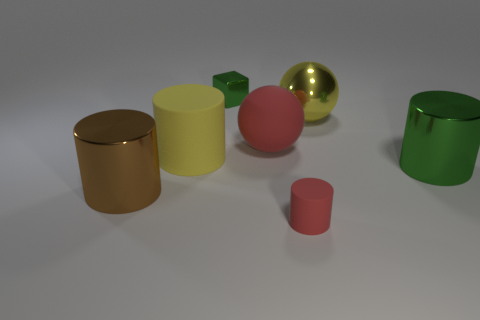Which object in the image is the brightest? The brightest object in the image is the golden yellow cylinder due to its high reflectivity and shiny surface. 